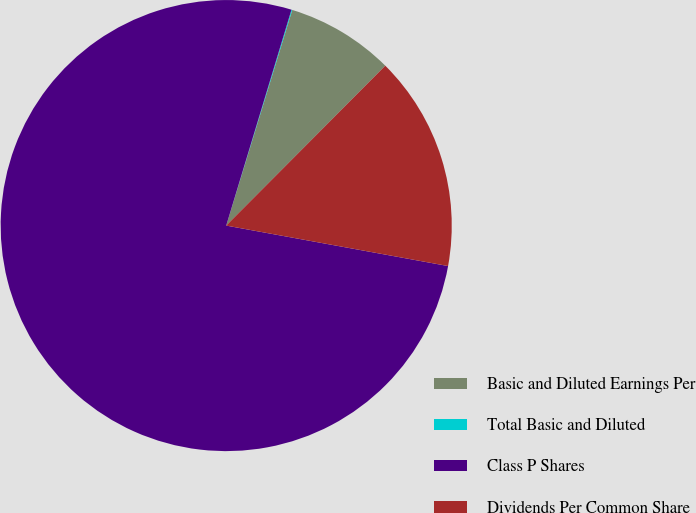Convert chart to OTSL. <chart><loc_0><loc_0><loc_500><loc_500><pie_chart><fcel>Basic and Diluted Earnings Per<fcel>Total Basic and Diluted<fcel>Class P Shares<fcel>Dividends Per Common Share<nl><fcel>7.73%<fcel>0.06%<fcel>76.8%<fcel>15.41%<nl></chart> 